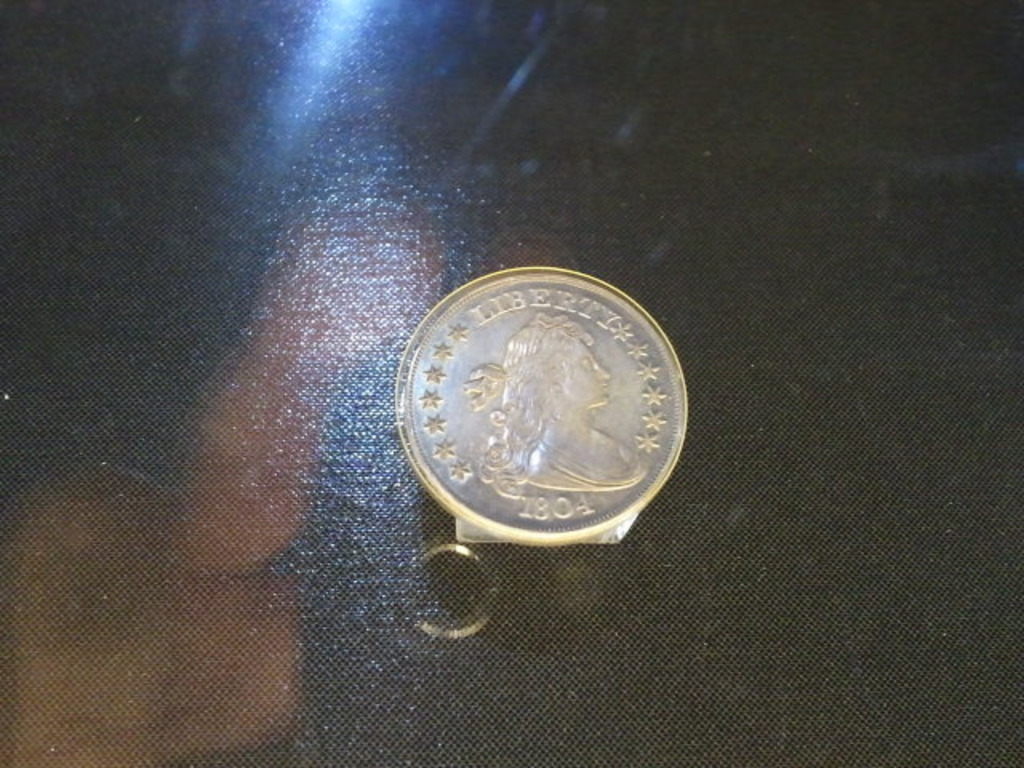Can you tell me more about the history of the 1804 silver dollar? Certainly! The 1804 silver dollar, also known as the Draped Bust dollar, is one of the rarest and most famous coins in American numismatics. Officially, none were actually struck in 1804 but in later years with that year's date for diplomatic gifts and for collectors. The specific varieties of these coins, such as the 'Class I' or 'King of Siam' set, are surrounded by mystery and stories befitting their rare stature. 